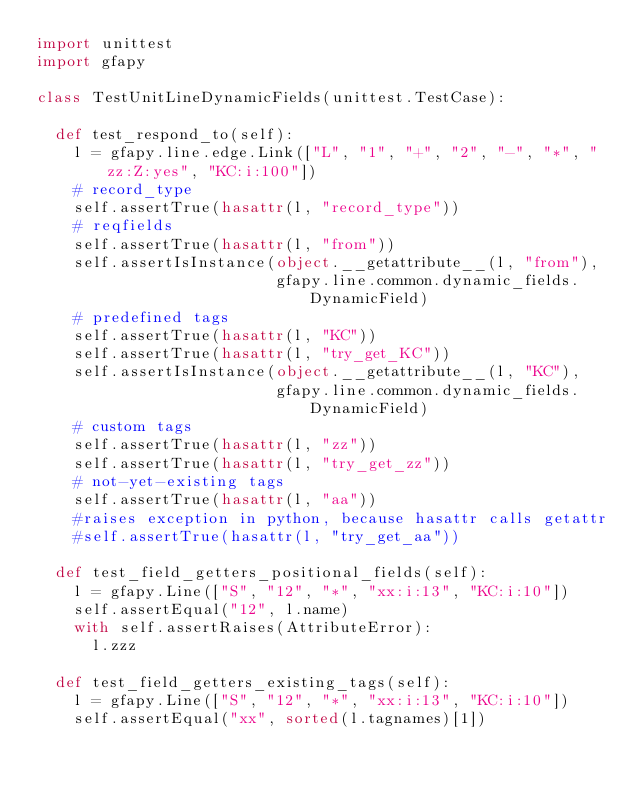Convert code to text. <code><loc_0><loc_0><loc_500><loc_500><_Python_>import unittest
import gfapy

class TestUnitLineDynamicFields(unittest.TestCase):

  def test_respond_to(self):
    l = gfapy.line.edge.Link(["L", "1", "+", "2", "-", "*", "zz:Z:yes", "KC:i:100"])
    # record_type
    self.assertTrue(hasattr(l, "record_type"))
    # reqfields
    self.assertTrue(hasattr(l, "from"))
    self.assertIsInstance(object.__getattribute__(l, "from"),
                          gfapy.line.common.dynamic_fields.DynamicField)
    # predefined tags
    self.assertTrue(hasattr(l, "KC"))
    self.assertTrue(hasattr(l, "try_get_KC"))
    self.assertIsInstance(object.__getattribute__(l, "KC"),
                          gfapy.line.common.dynamic_fields.DynamicField)
    # custom tags
    self.assertTrue(hasattr(l, "zz"))
    self.assertTrue(hasattr(l, "try_get_zz"))
    # not-yet-existing tags
    self.assertTrue(hasattr(l, "aa"))
    #raises exception in python, because hasattr calls getattr
    #self.assertTrue(hasattr(l, "try_get_aa"))

  def test_field_getters_positional_fields(self):
    l = gfapy.Line(["S", "12", "*", "xx:i:13", "KC:i:10"])
    self.assertEqual("12", l.name)
    with self.assertRaises(AttributeError):
      l.zzz

  def test_field_getters_existing_tags(self):
    l = gfapy.Line(["S", "12", "*", "xx:i:13", "KC:i:10"])
    self.assertEqual("xx", sorted(l.tagnames)[1])</code> 